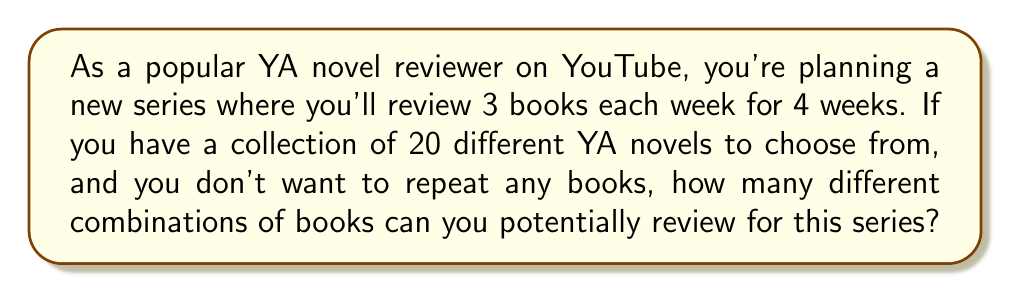Show me your answer to this math problem. Let's approach this step-by-step:

1) We need to select 3 books each week for 4 weeks, which means we're selecting a total of 12 books out of 20.

2) The order of selection within each week doesn't matter, but the order across weeks does (as it affects the content of each video).

3) This scenario can be modeled as a combination problem, specifically a combination with repetition.

4) The formula for combinations with repetition is:

   $${n+r-1 \choose r}$$

   Where $n$ is the number of types of objects (in this case, 20 books) and $r$ is the number of selections (in this case, 3 books per week).

5) We need to apply this formula for each week and then multiply the results:

   Week 1: ${20 \choose 3}$
   Week 2: ${17 \choose 3}$ (as 3 books have been used)
   Week 3: ${14 \choose 3}$ (as 6 books have been used)
   Week 4: ${11 \choose 3}$ (as 9 books have been used)

6) Let's calculate each of these:

   ${20 \choose 3} = \frac{20!}{3!(20-3)!} = 1140$
   ${17 \choose 3} = \frac{17!}{3!(17-3)!} = 680$
   ${14 \choose 3} = \frac{14!}{3!(14-3)!} = 364$
   ${11 \choose 3} = \frac{11!}{3!(11-3)!} = 165$

7) The total number of combinations is the product of these:

   $1140 \times 680 \times 364 \times 165 = 46,845,720,000$

Therefore, there are 46,845,720,000 different possible combinations of books for the YouTube series.
Answer: 46,845,720,000 